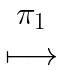Convert formula to latex. <formula><loc_0><loc_0><loc_500><loc_500>\begin{matrix} { \pi _ { 1 } } \\ \longmapsto \end{matrix}</formula> 